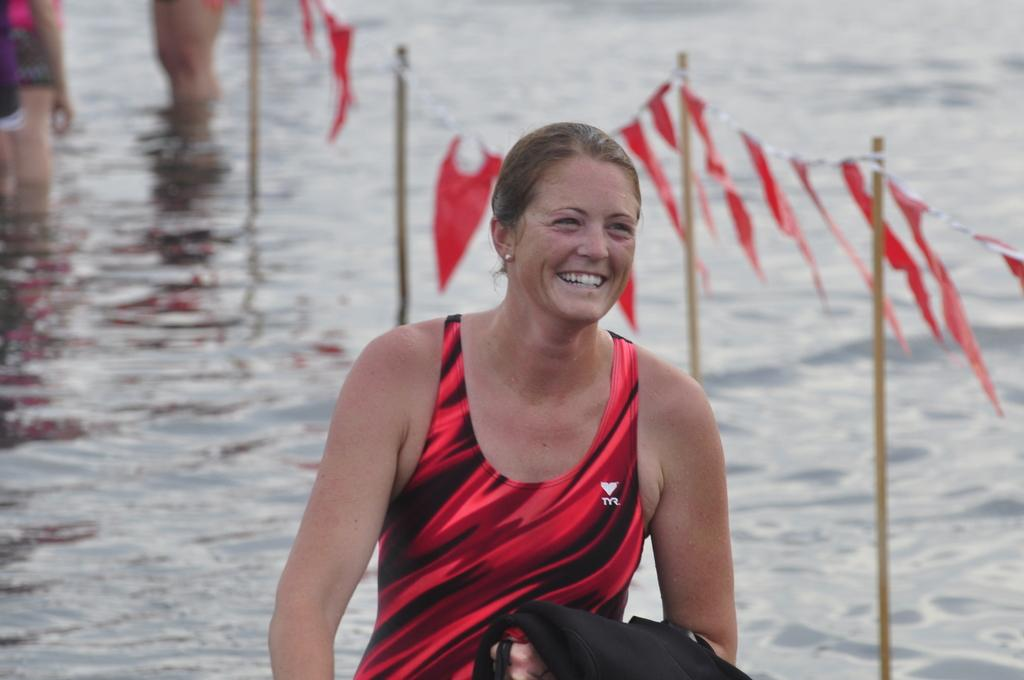Who is the main subject in the image? There is a woman in the image. Where is the woman located in relation to the image? The woman is in the foreground. What is the woman wearing? The woman is wearing a swimsuit. What is the woman's facial expression? The woman is smiling. What can be seen behind the woman? There is a lot of water behind the woman. How many cats are visible in the image? There are no cats present in the image. Was the woman affected by an earthquake in the image? There is no indication of an earthquake or any damage in the image. 